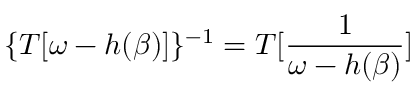<formula> <loc_0><loc_0><loc_500><loc_500>\{ T [ \omega - h ( \beta ) ] \} ^ { - 1 } = T [ \frac { 1 } { \omega - h ( \beta ) } ]</formula> 